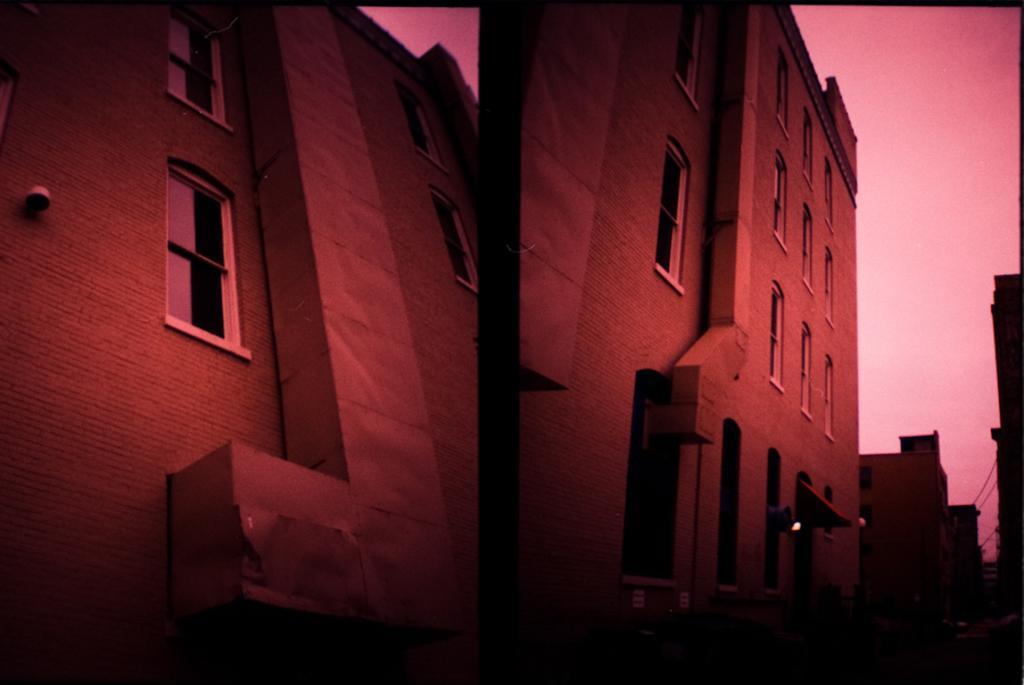Please provide a concise description of this image. In this picture we can see collage of two images, in these pictures we can see buildings, there is the sky at the top of the pictures, we can see windows of these buildings. 